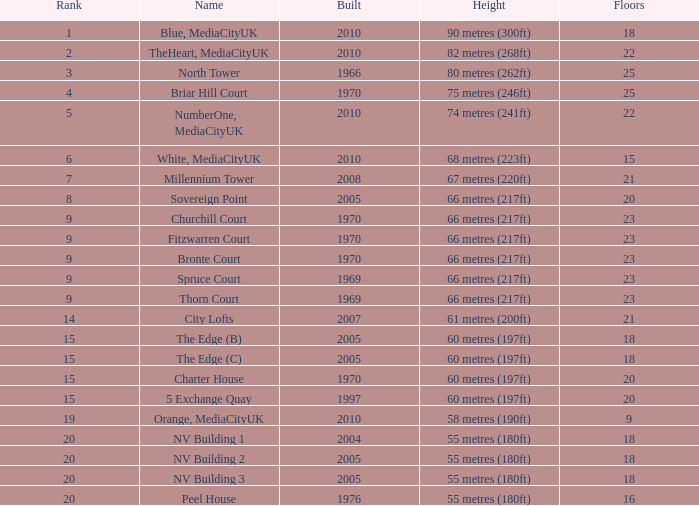I'm looking to parse the entire table for insights. Could you assist me with that? {'header': ['Rank', 'Name', 'Built', 'Height', 'Floors'], 'rows': [['1', 'Blue, MediaCityUK', '2010', '90 metres (300ft)', '18'], ['2', 'TheHeart, MediaCityUK', '2010', '82 metres (268ft)', '22'], ['3', 'North Tower', '1966', '80 metres (262ft)', '25'], ['4', 'Briar Hill Court', '1970', '75 metres (246ft)', '25'], ['5', 'NumberOne, MediaCityUK', '2010', '74 metres (241ft)', '22'], ['6', 'White, MediaCityUK', '2010', '68 metres (223ft)', '15'], ['7', 'Millennium Tower', '2008', '67 metres (220ft)', '21'], ['8', 'Sovereign Point', '2005', '66 metres (217ft)', '20'], ['9', 'Churchill Court', '1970', '66 metres (217ft)', '23'], ['9', 'Fitzwarren Court', '1970', '66 metres (217ft)', '23'], ['9', 'Bronte Court', '1970', '66 metres (217ft)', '23'], ['9', 'Spruce Court', '1969', '66 metres (217ft)', '23'], ['9', 'Thorn Court', '1969', '66 metres (217ft)', '23'], ['14', 'City Lofts', '2007', '61 metres (200ft)', '21'], ['15', 'The Edge (B)', '2005', '60 metres (197ft)', '18'], ['15', 'The Edge (C)', '2005', '60 metres (197ft)', '18'], ['15', 'Charter House', '1970', '60 metres (197ft)', '20'], ['15', '5 Exchange Quay', '1997', '60 metres (197ft)', '20'], ['19', 'Orange, MediaCityUK', '2010', '58 metres (190ft)', '9'], ['20', 'NV Building 1', '2004', '55 metres (180ft)', '18'], ['20', 'NV Building 2', '2005', '55 metres (180ft)', '18'], ['20', 'NV Building 3', '2005', '55 metres (180ft)', '18'], ['20', 'Peel House', '1976', '55 metres (180ft)', '16']]} What is the altitude, when rating is below 20, when storeys is more than 9, when established is 2005, and when moniker is the edge (c)? 60 metres (197ft). 